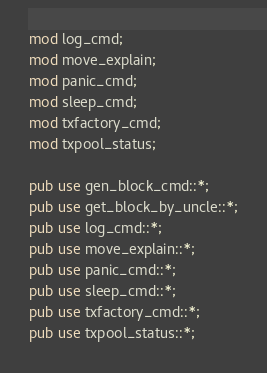Convert code to text. <code><loc_0><loc_0><loc_500><loc_500><_Rust_>mod log_cmd;
mod move_explain;
mod panic_cmd;
mod sleep_cmd;
mod txfactory_cmd;
mod txpool_status;

pub use gen_block_cmd::*;
pub use get_block_by_uncle::*;
pub use log_cmd::*;
pub use move_explain::*;
pub use panic_cmd::*;
pub use sleep_cmd::*;
pub use txfactory_cmd::*;
pub use txpool_status::*;
</code> 